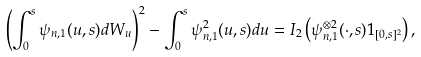<formula> <loc_0><loc_0><loc_500><loc_500>\left ( \int ^ { s } _ { 0 } \psi _ { n , 1 } ( u , s ) d W _ { u } \right ) ^ { 2 } - \int ^ { s } _ { 0 } \psi _ { n , 1 } ^ { 2 } ( u , s ) d u = I _ { 2 } \left ( \psi _ { n , 1 } ^ { \otimes 2 } ( \cdot , s ) 1 _ { [ 0 , s ] ^ { 2 } } \right ) ,</formula> 